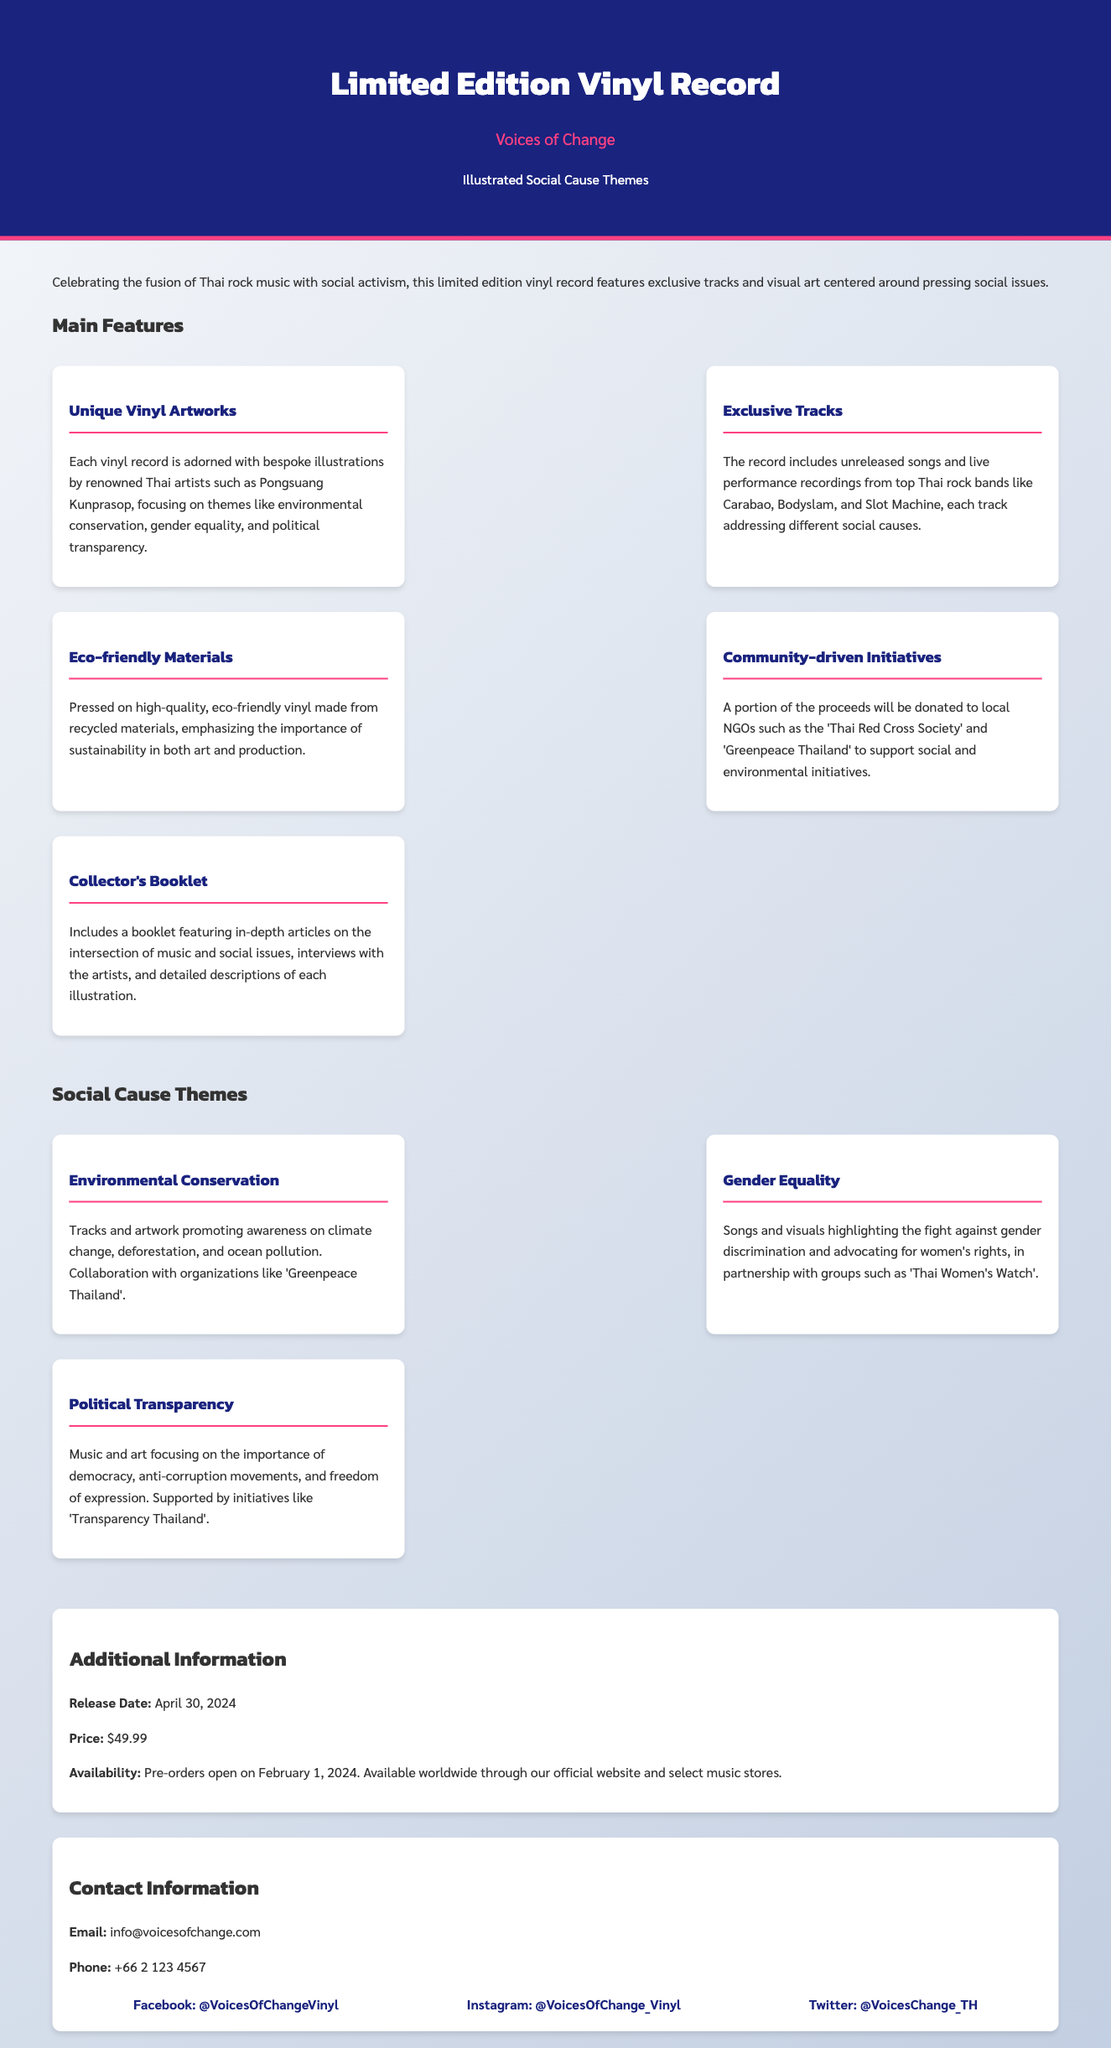what is the release date? The release date is specified in the additional information section of the document.
Answer: April 30, 2024 what is the price of the vinyl record? The price is stated in the additional information section of the document.
Answer: $49.99 who illustrated the vinyl artworks? The document mentions specific artists responsible for the illustrations included in the product.
Answer: Pongsuang Kunprasop which themes are highlighted in the social cause? The document lists specific social causes that the vinyl record addresses.
Answer: Environmental Conservation, Gender Equality, Political Transparency how can people contact for more information? The contact information section provides means to reach out for inquiries.
Answer: info@voicesofchange.com what portion of the proceeds goes to NGOs? The document states a contribution from the sales, indicating support for local NGOs.
Answer: A portion of the proceeds which organizations are partners for environmental themes? The document specifies collaborations with organizations for promoting environmental causes.
Answer: Greenpeace Thailand what type of materials is used for the vinyl? The document specifies the materials used for production, focusing on their ecological aspect.
Answer: Eco-friendly materials when do pre-orders open? The document clearly outlines the pre-order schedule for the vinyl record.
Answer: February 1, 2024 what is included in the collector's booklet? The document provides detail on what the booklet contains related to the vinyl.
Answer: In-depth articles, interviews, descriptions 